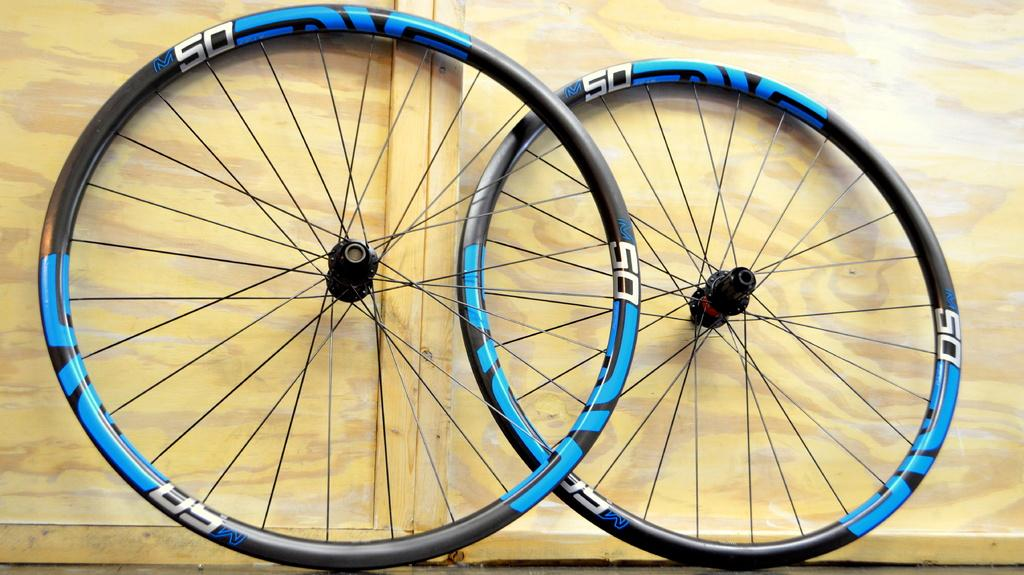What objects are present in the image that have wheels? There are two wheels in the image. What type of silk fabric is draped over the goldfish in the image? There is no silk fabric or goldfish present in the image; it only features two wheels. 